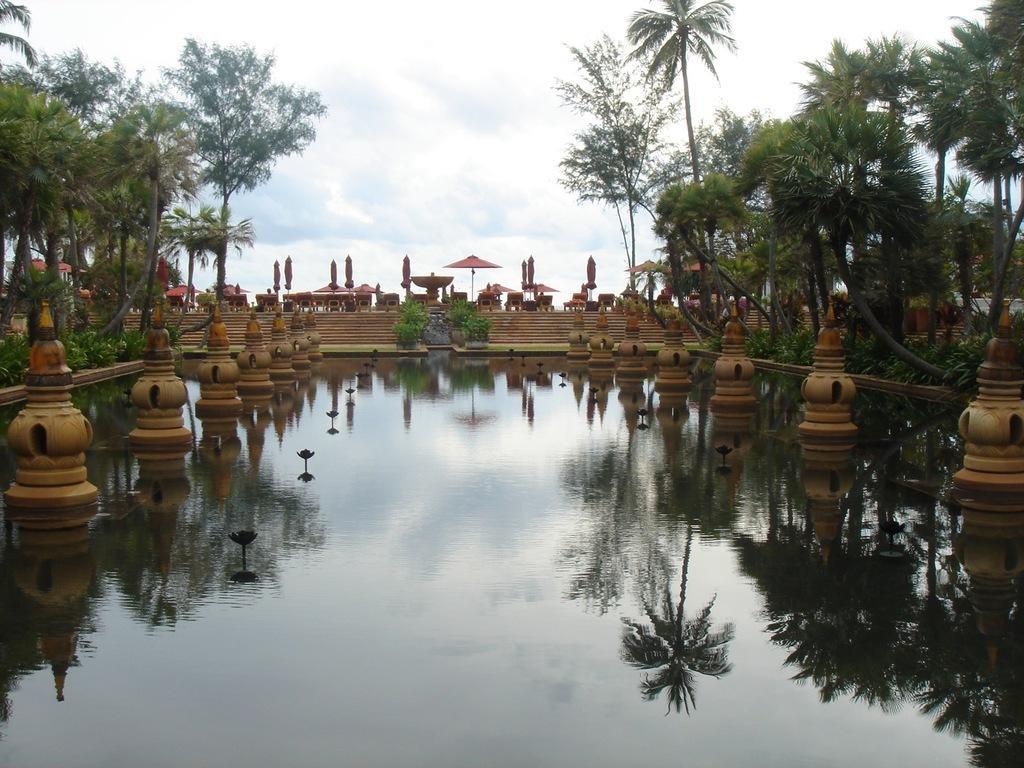Can you describe this image briefly? In this image I can see few brown color pillars in water, left and right I can see trees in green color. Background I can see sky in blue and white color. 